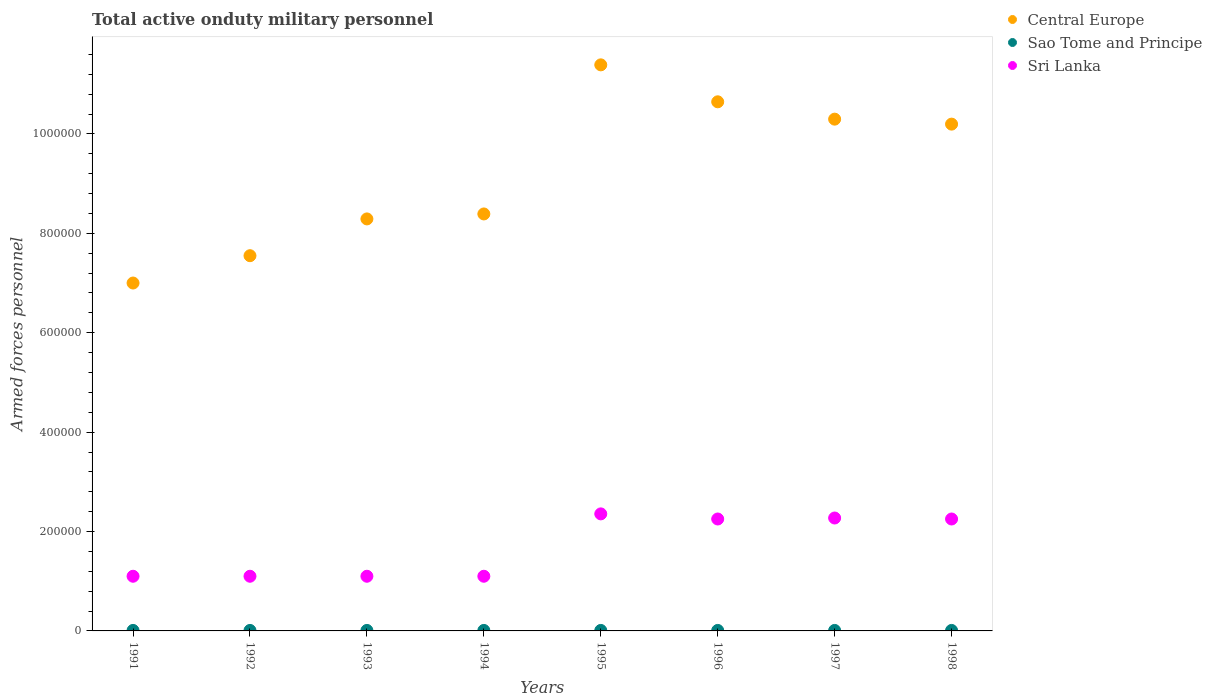How many different coloured dotlines are there?
Provide a short and direct response. 3. Is the number of dotlines equal to the number of legend labels?
Keep it short and to the point. Yes. What is the number of armed forces personnel in Central Europe in 1993?
Your answer should be compact. 8.29e+05. Across all years, what is the maximum number of armed forces personnel in Sri Lanka?
Provide a short and direct response. 2.36e+05. Across all years, what is the minimum number of armed forces personnel in Central Europe?
Give a very brief answer. 7.00e+05. In which year was the number of armed forces personnel in Sao Tome and Principe maximum?
Give a very brief answer. 1991. In which year was the number of armed forces personnel in Central Europe minimum?
Offer a terse response. 1991. What is the total number of armed forces personnel in Sri Lanka in the graph?
Offer a very short reply. 1.35e+06. What is the difference between the number of armed forces personnel in Sri Lanka in 1994 and that in 1995?
Offer a very short reply. -1.26e+05. What is the difference between the number of armed forces personnel in Central Europe in 1992 and the number of armed forces personnel in Sao Tome and Principe in 1994?
Keep it short and to the point. 7.54e+05. What is the average number of armed forces personnel in Central Europe per year?
Provide a succinct answer. 9.22e+05. In the year 1991, what is the difference between the number of armed forces personnel in Central Europe and number of armed forces personnel in Sao Tome and Principe?
Your answer should be compact. 6.99e+05. What is the ratio of the number of armed forces personnel in Sao Tome and Principe in 1996 to that in 1998?
Make the answer very short. 1. Is the number of armed forces personnel in Central Europe in 1993 less than that in 1997?
Give a very brief answer. Yes. Is the difference between the number of armed forces personnel in Central Europe in 1991 and 1993 greater than the difference between the number of armed forces personnel in Sao Tome and Principe in 1991 and 1993?
Your answer should be compact. No. What is the difference between the highest and the lowest number of armed forces personnel in Central Europe?
Your answer should be compact. 4.39e+05. Is the number of armed forces personnel in Central Europe strictly less than the number of armed forces personnel in Sao Tome and Principe over the years?
Your response must be concise. No. How many dotlines are there?
Your response must be concise. 3. How many years are there in the graph?
Give a very brief answer. 8. Are the values on the major ticks of Y-axis written in scientific E-notation?
Your answer should be compact. No. Does the graph contain any zero values?
Your response must be concise. No. Does the graph contain grids?
Your answer should be very brief. No. What is the title of the graph?
Ensure brevity in your answer.  Total active onduty military personnel. Does "Poland" appear as one of the legend labels in the graph?
Your answer should be compact. No. What is the label or title of the Y-axis?
Offer a terse response. Armed forces personnel. What is the Armed forces personnel of Central Europe in 1991?
Ensure brevity in your answer.  7.00e+05. What is the Armed forces personnel of Sri Lanka in 1991?
Provide a succinct answer. 1.10e+05. What is the Armed forces personnel in Central Europe in 1992?
Your response must be concise. 7.55e+05. What is the Armed forces personnel of Sao Tome and Principe in 1992?
Provide a short and direct response. 1000. What is the Armed forces personnel in Central Europe in 1993?
Make the answer very short. 8.29e+05. What is the Armed forces personnel in Sao Tome and Principe in 1993?
Your answer should be very brief. 1000. What is the Armed forces personnel in Central Europe in 1994?
Keep it short and to the point. 8.39e+05. What is the Armed forces personnel in Central Europe in 1995?
Offer a terse response. 1.14e+06. What is the Armed forces personnel in Sao Tome and Principe in 1995?
Offer a terse response. 1000. What is the Armed forces personnel in Sri Lanka in 1995?
Make the answer very short. 2.36e+05. What is the Armed forces personnel of Central Europe in 1996?
Your answer should be very brief. 1.06e+06. What is the Armed forces personnel of Sao Tome and Principe in 1996?
Make the answer very short. 1000. What is the Armed forces personnel of Sri Lanka in 1996?
Your answer should be compact. 2.25e+05. What is the Armed forces personnel of Central Europe in 1997?
Provide a short and direct response. 1.03e+06. What is the Armed forces personnel in Sao Tome and Principe in 1997?
Your answer should be very brief. 1000. What is the Armed forces personnel in Sri Lanka in 1997?
Keep it short and to the point. 2.27e+05. What is the Armed forces personnel of Central Europe in 1998?
Your answer should be very brief. 1.02e+06. What is the Armed forces personnel of Sao Tome and Principe in 1998?
Your answer should be compact. 1000. What is the Armed forces personnel in Sri Lanka in 1998?
Give a very brief answer. 2.25e+05. Across all years, what is the maximum Armed forces personnel of Central Europe?
Your answer should be compact. 1.14e+06. Across all years, what is the maximum Armed forces personnel of Sri Lanka?
Offer a very short reply. 2.36e+05. Across all years, what is the minimum Armed forces personnel of Sao Tome and Principe?
Keep it short and to the point. 1000. What is the total Armed forces personnel of Central Europe in the graph?
Make the answer very short. 7.38e+06. What is the total Armed forces personnel in Sao Tome and Principe in the graph?
Provide a succinct answer. 8000. What is the total Armed forces personnel in Sri Lanka in the graph?
Your answer should be compact. 1.35e+06. What is the difference between the Armed forces personnel in Central Europe in 1991 and that in 1992?
Offer a terse response. -5.50e+04. What is the difference between the Armed forces personnel of Sao Tome and Principe in 1991 and that in 1992?
Your answer should be very brief. 0. What is the difference between the Armed forces personnel in Central Europe in 1991 and that in 1993?
Keep it short and to the point. -1.29e+05. What is the difference between the Armed forces personnel of Sao Tome and Principe in 1991 and that in 1993?
Your answer should be compact. 0. What is the difference between the Armed forces personnel of Central Europe in 1991 and that in 1994?
Provide a short and direct response. -1.39e+05. What is the difference between the Armed forces personnel of Central Europe in 1991 and that in 1995?
Ensure brevity in your answer.  -4.39e+05. What is the difference between the Armed forces personnel of Sao Tome and Principe in 1991 and that in 1995?
Provide a short and direct response. 0. What is the difference between the Armed forces personnel of Sri Lanka in 1991 and that in 1995?
Ensure brevity in your answer.  -1.26e+05. What is the difference between the Armed forces personnel in Central Europe in 1991 and that in 1996?
Make the answer very short. -3.65e+05. What is the difference between the Armed forces personnel in Sri Lanka in 1991 and that in 1996?
Your response must be concise. -1.15e+05. What is the difference between the Armed forces personnel of Central Europe in 1991 and that in 1997?
Ensure brevity in your answer.  -3.30e+05. What is the difference between the Armed forces personnel of Sao Tome and Principe in 1991 and that in 1997?
Offer a terse response. 0. What is the difference between the Armed forces personnel in Sri Lanka in 1991 and that in 1997?
Provide a succinct answer. -1.17e+05. What is the difference between the Armed forces personnel in Central Europe in 1991 and that in 1998?
Offer a very short reply. -3.20e+05. What is the difference between the Armed forces personnel in Sri Lanka in 1991 and that in 1998?
Ensure brevity in your answer.  -1.15e+05. What is the difference between the Armed forces personnel of Central Europe in 1992 and that in 1993?
Give a very brief answer. -7.40e+04. What is the difference between the Armed forces personnel in Sri Lanka in 1992 and that in 1993?
Your answer should be compact. 0. What is the difference between the Armed forces personnel in Central Europe in 1992 and that in 1994?
Your response must be concise. -8.40e+04. What is the difference between the Armed forces personnel of Sao Tome and Principe in 1992 and that in 1994?
Provide a succinct answer. 0. What is the difference between the Armed forces personnel in Sri Lanka in 1992 and that in 1994?
Your answer should be very brief. 0. What is the difference between the Armed forces personnel in Central Europe in 1992 and that in 1995?
Make the answer very short. -3.84e+05. What is the difference between the Armed forces personnel in Sri Lanka in 1992 and that in 1995?
Make the answer very short. -1.26e+05. What is the difference between the Armed forces personnel in Central Europe in 1992 and that in 1996?
Keep it short and to the point. -3.10e+05. What is the difference between the Armed forces personnel of Sri Lanka in 1992 and that in 1996?
Offer a terse response. -1.15e+05. What is the difference between the Armed forces personnel in Central Europe in 1992 and that in 1997?
Offer a terse response. -2.75e+05. What is the difference between the Armed forces personnel in Sri Lanka in 1992 and that in 1997?
Your answer should be compact. -1.17e+05. What is the difference between the Armed forces personnel of Central Europe in 1992 and that in 1998?
Give a very brief answer. -2.65e+05. What is the difference between the Armed forces personnel in Sao Tome and Principe in 1992 and that in 1998?
Your answer should be very brief. 0. What is the difference between the Armed forces personnel of Sri Lanka in 1992 and that in 1998?
Make the answer very short. -1.15e+05. What is the difference between the Armed forces personnel in Central Europe in 1993 and that in 1994?
Offer a very short reply. -10000. What is the difference between the Armed forces personnel of Central Europe in 1993 and that in 1995?
Provide a succinct answer. -3.10e+05. What is the difference between the Armed forces personnel of Sri Lanka in 1993 and that in 1995?
Provide a short and direct response. -1.26e+05. What is the difference between the Armed forces personnel in Central Europe in 1993 and that in 1996?
Your response must be concise. -2.36e+05. What is the difference between the Armed forces personnel of Sao Tome and Principe in 1993 and that in 1996?
Provide a succinct answer. 0. What is the difference between the Armed forces personnel in Sri Lanka in 1993 and that in 1996?
Ensure brevity in your answer.  -1.15e+05. What is the difference between the Armed forces personnel of Central Europe in 1993 and that in 1997?
Provide a succinct answer. -2.01e+05. What is the difference between the Armed forces personnel of Sao Tome and Principe in 1993 and that in 1997?
Give a very brief answer. 0. What is the difference between the Armed forces personnel in Sri Lanka in 1993 and that in 1997?
Provide a succinct answer. -1.17e+05. What is the difference between the Armed forces personnel in Central Europe in 1993 and that in 1998?
Offer a terse response. -1.91e+05. What is the difference between the Armed forces personnel in Sri Lanka in 1993 and that in 1998?
Make the answer very short. -1.15e+05. What is the difference between the Armed forces personnel in Central Europe in 1994 and that in 1995?
Offer a terse response. -3.00e+05. What is the difference between the Armed forces personnel of Sao Tome and Principe in 1994 and that in 1995?
Ensure brevity in your answer.  0. What is the difference between the Armed forces personnel of Sri Lanka in 1994 and that in 1995?
Ensure brevity in your answer.  -1.26e+05. What is the difference between the Armed forces personnel of Central Europe in 1994 and that in 1996?
Provide a short and direct response. -2.26e+05. What is the difference between the Armed forces personnel of Sao Tome and Principe in 1994 and that in 1996?
Offer a very short reply. 0. What is the difference between the Armed forces personnel in Sri Lanka in 1994 and that in 1996?
Offer a very short reply. -1.15e+05. What is the difference between the Armed forces personnel of Central Europe in 1994 and that in 1997?
Your answer should be very brief. -1.91e+05. What is the difference between the Armed forces personnel in Sri Lanka in 1994 and that in 1997?
Ensure brevity in your answer.  -1.17e+05. What is the difference between the Armed forces personnel of Central Europe in 1994 and that in 1998?
Provide a succinct answer. -1.81e+05. What is the difference between the Armed forces personnel of Sri Lanka in 1994 and that in 1998?
Make the answer very short. -1.15e+05. What is the difference between the Armed forces personnel of Central Europe in 1995 and that in 1996?
Your answer should be very brief. 7.44e+04. What is the difference between the Armed forces personnel in Sri Lanka in 1995 and that in 1996?
Your answer should be very brief. 1.03e+04. What is the difference between the Armed forces personnel of Central Europe in 1995 and that in 1997?
Make the answer very short. 1.09e+05. What is the difference between the Armed forces personnel in Sao Tome and Principe in 1995 and that in 1997?
Your response must be concise. 0. What is the difference between the Armed forces personnel in Sri Lanka in 1995 and that in 1997?
Keep it short and to the point. 8300. What is the difference between the Armed forces personnel in Central Europe in 1995 and that in 1998?
Offer a terse response. 1.19e+05. What is the difference between the Armed forces personnel of Sri Lanka in 1995 and that in 1998?
Give a very brief answer. 1.03e+04. What is the difference between the Armed forces personnel in Central Europe in 1996 and that in 1997?
Give a very brief answer. 3.49e+04. What is the difference between the Armed forces personnel in Sao Tome and Principe in 1996 and that in 1997?
Offer a very short reply. 0. What is the difference between the Armed forces personnel in Sri Lanka in 1996 and that in 1997?
Keep it short and to the point. -2000. What is the difference between the Armed forces personnel of Central Europe in 1996 and that in 1998?
Give a very brief answer. 4.49e+04. What is the difference between the Armed forces personnel in Sao Tome and Principe in 1996 and that in 1998?
Offer a very short reply. 0. What is the difference between the Armed forces personnel in Central Europe in 1997 and that in 1998?
Keep it short and to the point. 1.00e+04. What is the difference between the Armed forces personnel in Central Europe in 1991 and the Armed forces personnel in Sao Tome and Principe in 1992?
Offer a terse response. 6.99e+05. What is the difference between the Armed forces personnel of Central Europe in 1991 and the Armed forces personnel of Sri Lanka in 1992?
Provide a succinct answer. 5.90e+05. What is the difference between the Armed forces personnel in Sao Tome and Principe in 1991 and the Armed forces personnel in Sri Lanka in 1992?
Your answer should be compact. -1.09e+05. What is the difference between the Armed forces personnel in Central Europe in 1991 and the Armed forces personnel in Sao Tome and Principe in 1993?
Provide a succinct answer. 6.99e+05. What is the difference between the Armed forces personnel in Central Europe in 1991 and the Armed forces personnel in Sri Lanka in 1993?
Offer a very short reply. 5.90e+05. What is the difference between the Armed forces personnel in Sao Tome and Principe in 1991 and the Armed forces personnel in Sri Lanka in 1993?
Give a very brief answer. -1.09e+05. What is the difference between the Armed forces personnel in Central Europe in 1991 and the Armed forces personnel in Sao Tome and Principe in 1994?
Ensure brevity in your answer.  6.99e+05. What is the difference between the Armed forces personnel of Central Europe in 1991 and the Armed forces personnel of Sri Lanka in 1994?
Provide a succinct answer. 5.90e+05. What is the difference between the Armed forces personnel of Sao Tome and Principe in 1991 and the Armed forces personnel of Sri Lanka in 1994?
Ensure brevity in your answer.  -1.09e+05. What is the difference between the Armed forces personnel in Central Europe in 1991 and the Armed forces personnel in Sao Tome and Principe in 1995?
Keep it short and to the point. 6.99e+05. What is the difference between the Armed forces personnel in Central Europe in 1991 and the Armed forces personnel in Sri Lanka in 1995?
Offer a terse response. 4.64e+05. What is the difference between the Armed forces personnel in Sao Tome and Principe in 1991 and the Armed forces personnel in Sri Lanka in 1995?
Ensure brevity in your answer.  -2.34e+05. What is the difference between the Armed forces personnel of Central Europe in 1991 and the Armed forces personnel of Sao Tome and Principe in 1996?
Provide a short and direct response. 6.99e+05. What is the difference between the Armed forces personnel of Central Europe in 1991 and the Armed forces personnel of Sri Lanka in 1996?
Offer a very short reply. 4.75e+05. What is the difference between the Armed forces personnel of Sao Tome and Principe in 1991 and the Armed forces personnel of Sri Lanka in 1996?
Offer a very short reply. -2.24e+05. What is the difference between the Armed forces personnel in Central Europe in 1991 and the Armed forces personnel in Sao Tome and Principe in 1997?
Provide a short and direct response. 6.99e+05. What is the difference between the Armed forces personnel in Central Europe in 1991 and the Armed forces personnel in Sri Lanka in 1997?
Your answer should be compact. 4.73e+05. What is the difference between the Armed forces personnel of Sao Tome and Principe in 1991 and the Armed forces personnel of Sri Lanka in 1997?
Give a very brief answer. -2.26e+05. What is the difference between the Armed forces personnel in Central Europe in 1991 and the Armed forces personnel in Sao Tome and Principe in 1998?
Offer a terse response. 6.99e+05. What is the difference between the Armed forces personnel in Central Europe in 1991 and the Armed forces personnel in Sri Lanka in 1998?
Ensure brevity in your answer.  4.75e+05. What is the difference between the Armed forces personnel of Sao Tome and Principe in 1991 and the Armed forces personnel of Sri Lanka in 1998?
Your answer should be compact. -2.24e+05. What is the difference between the Armed forces personnel in Central Europe in 1992 and the Armed forces personnel in Sao Tome and Principe in 1993?
Provide a short and direct response. 7.54e+05. What is the difference between the Armed forces personnel of Central Europe in 1992 and the Armed forces personnel of Sri Lanka in 1993?
Provide a short and direct response. 6.45e+05. What is the difference between the Armed forces personnel of Sao Tome and Principe in 1992 and the Armed forces personnel of Sri Lanka in 1993?
Make the answer very short. -1.09e+05. What is the difference between the Armed forces personnel in Central Europe in 1992 and the Armed forces personnel in Sao Tome and Principe in 1994?
Your answer should be compact. 7.54e+05. What is the difference between the Armed forces personnel of Central Europe in 1992 and the Armed forces personnel of Sri Lanka in 1994?
Your response must be concise. 6.45e+05. What is the difference between the Armed forces personnel in Sao Tome and Principe in 1992 and the Armed forces personnel in Sri Lanka in 1994?
Make the answer very short. -1.09e+05. What is the difference between the Armed forces personnel of Central Europe in 1992 and the Armed forces personnel of Sao Tome and Principe in 1995?
Your answer should be compact. 7.54e+05. What is the difference between the Armed forces personnel in Central Europe in 1992 and the Armed forces personnel in Sri Lanka in 1995?
Offer a very short reply. 5.20e+05. What is the difference between the Armed forces personnel of Sao Tome and Principe in 1992 and the Armed forces personnel of Sri Lanka in 1995?
Give a very brief answer. -2.34e+05. What is the difference between the Armed forces personnel in Central Europe in 1992 and the Armed forces personnel in Sao Tome and Principe in 1996?
Offer a terse response. 7.54e+05. What is the difference between the Armed forces personnel in Central Europe in 1992 and the Armed forces personnel in Sri Lanka in 1996?
Offer a very short reply. 5.30e+05. What is the difference between the Armed forces personnel in Sao Tome and Principe in 1992 and the Armed forces personnel in Sri Lanka in 1996?
Provide a succinct answer. -2.24e+05. What is the difference between the Armed forces personnel of Central Europe in 1992 and the Armed forces personnel of Sao Tome and Principe in 1997?
Your answer should be very brief. 7.54e+05. What is the difference between the Armed forces personnel in Central Europe in 1992 and the Armed forces personnel in Sri Lanka in 1997?
Give a very brief answer. 5.28e+05. What is the difference between the Armed forces personnel of Sao Tome and Principe in 1992 and the Armed forces personnel of Sri Lanka in 1997?
Make the answer very short. -2.26e+05. What is the difference between the Armed forces personnel in Central Europe in 1992 and the Armed forces personnel in Sao Tome and Principe in 1998?
Make the answer very short. 7.54e+05. What is the difference between the Armed forces personnel in Central Europe in 1992 and the Armed forces personnel in Sri Lanka in 1998?
Offer a terse response. 5.30e+05. What is the difference between the Armed forces personnel in Sao Tome and Principe in 1992 and the Armed forces personnel in Sri Lanka in 1998?
Your answer should be compact. -2.24e+05. What is the difference between the Armed forces personnel of Central Europe in 1993 and the Armed forces personnel of Sao Tome and Principe in 1994?
Your answer should be very brief. 8.28e+05. What is the difference between the Armed forces personnel of Central Europe in 1993 and the Armed forces personnel of Sri Lanka in 1994?
Your response must be concise. 7.19e+05. What is the difference between the Armed forces personnel of Sao Tome and Principe in 1993 and the Armed forces personnel of Sri Lanka in 1994?
Your answer should be very brief. -1.09e+05. What is the difference between the Armed forces personnel in Central Europe in 1993 and the Armed forces personnel in Sao Tome and Principe in 1995?
Keep it short and to the point. 8.28e+05. What is the difference between the Armed forces personnel in Central Europe in 1993 and the Armed forces personnel in Sri Lanka in 1995?
Ensure brevity in your answer.  5.94e+05. What is the difference between the Armed forces personnel in Sao Tome and Principe in 1993 and the Armed forces personnel in Sri Lanka in 1995?
Offer a terse response. -2.34e+05. What is the difference between the Armed forces personnel of Central Europe in 1993 and the Armed forces personnel of Sao Tome and Principe in 1996?
Keep it short and to the point. 8.28e+05. What is the difference between the Armed forces personnel in Central Europe in 1993 and the Armed forces personnel in Sri Lanka in 1996?
Offer a very short reply. 6.04e+05. What is the difference between the Armed forces personnel of Sao Tome and Principe in 1993 and the Armed forces personnel of Sri Lanka in 1996?
Your response must be concise. -2.24e+05. What is the difference between the Armed forces personnel in Central Europe in 1993 and the Armed forces personnel in Sao Tome and Principe in 1997?
Ensure brevity in your answer.  8.28e+05. What is the difference between the Armed forces personnel in Central Europe in 1993 and the Armed forces personnel in Sri Lanka in 1997?
Ensure brevity in your answer.  6.02e+05. What is the difference between the Armed forces personnel in Sao Tome and Principe in 1993 and the Armed forces personnel in Sri Lanka in 1997?
Your answer should be compact. -2.26e+05. What is the difference between the Armed forces personnel of Central Europe in 1993 and the Armed forces personnel of Sao Tome and Principe in 1998?
Your answer should be very brief. 8.28e+05. What is the difference between the Armed forces personnel in Central Europe in 1993 and the Armed forces personnel in Sri Lanka in 1998?
Your answer should be compact. 6.04e+05. What is the difference between the Armed forces personnel in Sao Tome and Principe in 1993 and the Armed forces personnel in Sri Lanka in 1998?
Keep it short and to the point. -2.24e+05. What is the difference between the Armed forces personnel of Central Europe in 1994 and the Armed forces personnel of Sao Tome and Principe in 1995?
Offer a terse response. 8.38e+05. What is the difference between the Armed forces personnel in Central Europe in 1994 and the Armed forces personnel in Sri Lanka in 1995?
Give a very brief answer. 6.04e+05. What is the difference between the Armed forces personnel in Sao Tome and Principe in 1994 and the Armed forces personnel in Sri Lanka in 1995?
Make the answer very short. -2.34e+05. What is the difference between the Armed forces personnel in Central Europe in 1994 and the Armed forces personnel in Sao Tome and Principe in 1996?
Your answer should be very brief. 8.38e+05. What is the difference between the Armed forces personnel of Central Europe in 1994 and the Armed forces personnel of Sri Lanka in 1996?
Offer a very short reply. 6.14e+05. What is the difference between the Armed forces personnel in Sao Tome and Principe in 1994 and the Armed forces personnel in Sri Lanka in 1996?
Provide a succinct answer. -2.24e+05. What is the difference between the Armed forces personnel in Central Europe in 1994 and the Armed forces personnel in Sao Tome and Principe in 1997?
Your response must be concise. 8.38e+05. What is the difference between the Armed forces personnel of Central Europe in 1994 and the Armed forces personnel of Sri Lanka in 1997?
Your answer should be compact. 6.12e+05. What is the difference between the Armed forces personnel of Sao Tome and Principe in 1994 and the Armed forces personnel of Sri Lanka in 1997?
Make the answer very short. -2.26e+05. What is the difference between the Armed forces personnel of Central Europe in 1994 and the Armed forces personnel of Sao Tome and Principe in 1998?
Your response must be concise. 8.38e+05. What is the difference between the Armed forces personnel in Central Europe in 1994 and the Armed forces personnel in Sri Lanka in 1998?
Ensure brevity in your answer.  6.14e+05. What is the difference between the Armed forces personnel in Sao Tome and Principe in 1994 and the Armed forces personnel in Sri Lanka in 1998?
Offer a terse response. -2.24e+05. What is the difference between the Armed forces personnel of Central Europe in 1995 and the Armed forces personnel of Sao Tome and Principe in 1996?
Provide a short and direct response. 1.14e+06. What is the difference between the Armed forces personnel of Central Europe in 1995 and the Armed forces personnel of Sri Lanka in 1996?
Ensure brevity in your answer.  9.14e+05. What is the difference between the Armed forces personnel in Sao Tome and Principe in 1995 and the Armed forces personnel in Sri Lanka in 1996?
Provide a succinct answer. -2.24e+05. What is the difference between the Armed forces personnel in Central Europe in 1995 and the Armed forces personnel in Sao Tome and Principe in 1997?
Provide a short and direct response. 1.14e+06. What is the difference between the Armed forces personnel in Central Europe in 1995 and the Armed forces personnel in Sri Lanka in 1997?
Offer a very short reply. 9.12e+05. What is the difference between the Armed forces personnel of Sao Tome and Principe in 1995 and the Armed forces personnel of Sri Lanka in 1997?
Your response must be concise. -2.26e+05. What is the difference between the Armed forces personnel of Central Europe in 1995 and the Armed forces personnel of Sao Tome and Principe in 1998?
Ensure brevity in your answer.  1.14e+06. What is the difference between the Armed forces personnel of Central Europe in 1995 and the Armed forces personnel of Sri Lanka in 1998?
Your answer should be very brief. 9.14e+05. What is the difference between the Armed forces personnel of Sao Tome and Principe in 1995 and the Armed forces personnel of Sri Lanka in 1998?
Make the answer very short. -2.24e+05. What is the difference between the Armed forces personnel in Central Europe in 1996 and the Armed forces personnel in Sao Tome and Principe in 1997?
Offer a terse response. 1.06e+06. What is the difference between the Armed forces personnel of Central Europe in 1996 and the Armed forces personnel of Sri Lanka in 1997?
Ensure brevity in your answer.  8.37e+05. What is the difference between the Armed forces personnel in Sao Tome and Principe in 1996 and the Armed forces personnel in Sri Lanka in 1997?
Provide a succinct answer. -2.26e+05. What is the difference between the Armed forces personnel of Central Europe in 1996 and the Armed forces personnel of Sao Tome and Principe in 1998?
Ensure brevity in your answer.  1.06e+06. What is the difference between the Armed forces personnel of Central Europe in 1996 and the Armed forces personnel of Sri Lanka in 1998?
Your response must be concise. 8.39e+05. What is the difference between the Armed forces personnel of Sao Tome and Principe in 1996 and the Armed forces personnel of Sri Lanka in 1998?
Give a very brief answer. -2.24e+05. What is the difference between the Armed forces personnel of Central Europe in 1997 and the Armed forces personnel of Sao Tome and Principe in 1998?
Your answer should be very brief. 1.03e+06. What is the difference between the Armed forces personnel of Central Europe in 1997 and the Armed forces personnel of Sri Lanka in 1998?
Ensure brevity in your answer.  8.05e+05. What is the difference between the Armed forces personnel in Sao Tome and Principe in 1997 and the Armed forces personnel in Sri Lanka in 1998?
Make the answer very short. -2.24e+05. What is the average Armed forces personnel in Central Europe per year?
Your response must be concise. 9.22e+05. What is the average Armed forces personnel of Sri Lanka per year?
Your answer should be compact. 1.69e+05. In the year 1991, what is the difference between the Armed forces personnel of Central Europe and Armed forces personnel of Sao Tome and Principe?
Provide a short and direct response. 6.99e+05. In the year 1991, what is the difference between the Armed forces personnel of Central Europe and Armed forces personnel of Sri Lanka?
Make the answer very short. 5.90e+05. In the year 1991, what is the difference between the Armed forces personnel in Sao Tome and Principe and Armed forces personnel in Sri Lanka?
Your answer should be compact. -1.09e+05. In the year 1992, what is the difference between the Armed forces personnel in Central Europe and Armed forces personnel in Sao Tome and Principe?
Ensure brevity in your answer.  7.54e+05. In the year 1992, what is the difference between the Armed forces personnel in Central Europe and Armed forces personnel in Sri Lanka?
Offer a terse response. 6.45e+05. In the year 1992, what is the difference between the Armed forces personnel in Sao Tome and Principe and Armed forces personnel in Sri Lanka?
Your answer should be very brief. -1.09e+05. In the year 1993, what is the difference between the Armed forces personnel of Central Europe and Armed forces personnel of Sao Tome and Principe?
Give a very brief answer. 8.28e+05. In the year 1993, what is the difference between the Armed forces personnel of Central Europe and Armed forces personnel of Sri Lanka?
Your answer should be very brief. 7.19e+05. In the year 1993, what is the difference between the Armed forces personnel in Sao Tome and Principe and Armed forces personnel in Sri Lanka?
Keep it short and to the point. -1.09e+05. In the year 1994, what is the difference between the Armed forces personnel in Central Europe and Armed forces personnel in Sao Tome and Principe?
Give a very brief answer. 8.38e+05. In the year 1994, what is the difference between the Armed forces personnel in Central Europe and Armed forces personnel in Sri Lanka?
Offer a very short reply. 7.29e+05. In the year 1994, what is the difference between the Armed forces personnel of Sao Tome and Principe and Armed forces personnel of Sri Lanka?
Ensure brevity in your answer.  -1.09e+05. In the year 1995, what is the difference between the Armed forces personnel of Central Europe and Armed forces personnel of Sao Tome and Principe?
Give a very brief answer. 1.14e+06. In the year 1995, what is the difference between the Armed forces personnel in Central Europe and Armed forces personnel in Sri Lanka?
Offer a terse response. 9.04e+05. In the year 1995, what is the difference between the Armed forces personnel in Sao Tome and Principe and Armed forces personnel in Sri Lanka?
Your answer should be very brief. -2.34e+05. In the year 1996, what is the difference between the Armed forces personnel of Central Europe and Armed forces personnel of Sao Tome and Principe?
Your response must be concise. 1.06e+06. In the year 1996, what is the difference between the Armed forces personnel in Central Europe and Armed forces personnel in Sri Lanka?
Keep it short and to the point. 8.39e+05. In the year 1996, what is the difference between the Armed forces personnel in Sao Tome and Principe and Armed forces personnel in Sri Lanka?
Make the answer very short. -2.24e+05. In the year 1997, what is the difference between the Armed forces personnel of Central Europe and Armed forces personnel of Sao Tome and Principe?
Offer a terse response. 1.03e+06. In the year 1997, what is the difference between the Armed forces personnel of Central Europe and Armed forces personnel of Sri Lanka?
Keep it short and to the point. 8.03e+05. In the year 1997, what is the difference between the Armed forces personnel of Sao Tome and Principe and Armed forces personnel of Sri Lanka?
Provide a succinct answer. -2.26e+05. In the year 1998, what is the difference between the Armed forces personnel of Central Europe and Armed forces personnel of Sao Tome and Principe?
Keep it short and to the point. 1.02e+06. In the year 1998, what is the difference between the Armed forces personnel in Central Europe and Armed forces personnel in Sri Lanka?
Provide a succinct answer. 7.95e+05. In the year 1998, what is the difference between the Armed forces personnel of Sao Tome and Principe and Armed forces personnel of Sri Lanka?
Your answer should be very brief. -2.24e+05. What is the ratio of the Armed forces personnel of Central Europe in 1991 to that in 1992?
Provide a short and direct response. 0.93. What is the ratio of the Armed forces personnel of Central Europe in 1991 to that in 1993?
Provide a short and direct response. 0.84. What is the ratio of the Armed forces personnel of Central Europe in 1991 to that in 1994?
Provide a short and direct response. 0.83. What is the ratio of the Armed forces personnel of Sao Tome and Principe in 1991 to that in 1994?
Your answer should be very brief. 1. What is the ratio of the Armed forces personnel in Sri Lanka in 1991 to that in 1994?
Make the answer very short. 1. What is the ratio of the Armed forces personnel in Central Europe in 1991 to that in 1995?
Make the answer very short. 0.61. What is the ratio of the Armed forces personnel of Sao Tome and Principe in 1991 to that in 1995?
Ensure brevity in your answer.  1. What is the ratio of the Armed forces personnel of Sri Lanka in 1991 to that in 1995?
Offer a very short reply. 0.47. What is the ratio of the Armed forces personnel of Central Europe in 1991 to that in 1996?
Your answer should be compact. 0.66. What is the ratio of the Armed forces personnel of Sri Lanka in 1991 to that in 1996?
Your answer should be compact. 0.49. What is the ratio of the Armed forces personnel of Central Europe in 1991 to that in 1997?
Offer a very short reply. 0.68. What is the ratio of the Armed forces personnel in Sri Lanka in 1991 to that in 1997?
Offer a terse response. 0.48. What is the ratio of the Armed forces personnel in Central Europe in 1991 to that in 1998?
Ensure brevity in your answer.  0.69. What is the ratio of the Armed forces personnel in Sao Tome and Principe in 1991 to that in 1998?
Your response must be concise. 1. What is the ratio of the Armed forces personnel of Sri Lanka in 1991 to that in 1998?
Provide a succinct answer. 0.49. What is the ratio of the Armed forces personnel in Central Europe in 1992 to that in 1993?
Offer a very short reply. 0.91. What is the ratio of the Armed forces personnel of Sri Lanka in 1992 to that in 1993?
Offer a terse response. 1. What is the ratio of the Armed forces personnel in Central Europe in 1992 to that in 1994?
Offer a very short reply. 0.9. What is the ratio of the Armed forces personnel in Central Europe in 1992 to that in 1995?
Ensure brevity in your answer.  0.66. What is the ratio of the Armed forces personnel in Sri Lanka in 1992 to that in 1995?
Your answer should be very brief. 0.47. What is the ratio of the Armed forces personnel in Central Europe in 1992 to that in 1996?
Make the answer very short. 0.71. What is the ratio of the Armed forces personnel in Sao Tome and Principe in 1992 to that in 1996?
Offer a terse response. 1. What is the ratio of the Armed forces personnel in Sri Lanka in 1992 to that in 1996?
Make the answer very short. 0.49. What is the ratio of the Armed forces personnel in Central Europe in 1992 to that in 1997?
Provide a succinct answer. 0.73. What is the ratio of the Armed forces personnel in Sao Tome and Principe in 1992 to that in 1997?
Provide a short and direct response. 1. What is the ratio of the Armed forces personnel of Sri Lanka in 1992 to that in 1997?
Provide a succinct answer. 0.48. What is the ratio of the Armed forces personnel in Central Europe in 1992 to that in 1998?
Give a very brief answer. 0.74. What is the ratio of the Armed forces personnel in Sao Tome and Principe in 1992 to that in 1998?
Give a very brief answer. 1. What is the ratio of the Armed forces personnel in Sri Lanka in 1992 to that in 1998?
Ensure brevity in your answer.  0.49. What is the ratio of the Armed forces personnel of Central Europe in 1993 to that in 1994?
Offer a terse response. 0.99. What is the ratio of the Armed forces personnel in Sao Tome and Principe in 1993 to that in 1994?
Make the answer very short. 1. What is the ratio of the Armed forces personnel in Central Europe in 1993 to that in 1995?
Ensure brevity in your answer.  0.73. What is the ratio of the Armed forces personnel in Sri Lanka in 1993 to that in 1995?
Provide a succinct answer. 0.47. What is the ratio of the Armed forces personnel of Central Europe in 1993 to that in 1996?
Your answer should be compact. 0.78. What is the ratio of the Armed forces personnel in Sri Lanka in 1993 to that in 1996?
Give a very brief answer. 0.49. What is the ratio of the Armed forces personnel in Central Europe in 1993 to that in 1997?
Provide a succinct answer. 0.81. What is the ratio of the Armed forces personnel of Sao Tome and Principe in 1993 to that in 1997?
Provide a short and direct response. 1. What is the ratio of the Armed forces personnel of Sri Lanka in 1993 to that in 1997?
Offer a very short reply. 0.48. What is the ratio of the Armed forces personnel of Central Europe in 1993 to that in 1998?
Offer a terse response. 0.81. What is the ratio of the Armed forces personnel of Sri Lanka in 1993 to that in 1998?
Give a very brief answer. 0.49. What is the ratio of the Armed forces personnel in Central Europe in 1994 to that in 1995?
Your response must be concise. 0.74. What is the ratio of the Armed forces personnel of Sri Lanka in 1994 to that in 1995?
Your answer should be compact. 0.47. What is the ratio of the Armed forces personnel of Central Europe in 1994 to that in 1996?
Provide a succinct answer. 0.79. What is the ratio of the Armed forces personnel in Sao Tome and Principe in 1994 to that in 1996?
Provide a succinct answer. 1. What is the ratio of the Armed forces personnel of Sri Lanka in 1994 to that in 1996?
Provide a short and direct response. 0.49. What is the ratio of the Armed forces personnel of Central Europe in 1994 to that in 1997?
Ensure brevity in your answer.  0.81. What is the ratio of the Armed forces personnel in Sri Lanka in 1994 to that in 1997?
Your response must be concise. 0.48. What is the ratio of the Armed forces personnel of Central Europe in 1994 to that in 1998?
Offer a very short reply. 0.82. What is the ratio of the Armed forces personnel in Sao Tome and Principe in 1994 to that in 1998?
Your response must be concise. 1. What is the ratio of the Armed forces personnel of Sri Lanka in 1994 to that in 1998?
Make the answer very short. 0.49. What is the ratio of the Armed forces personnel of Central Europe in 1995 to that in 1996?
Offer a terse response. 1.07. What is the ratio of the Armed forces personnel in Sri Lanka in 1995 to that in 1996?
Offer a terse response. 1.05. What is the ratio of the Armed forces personnel of Central Europe in 1995 to that in 1997?
Offer a very short reply. 1.11. What is the ratio of the Armed forces personnel in Sao Tome and Principe in 1995 to that in 1997?
Your response must be concise. 1. What is the ratio of the Armed forces personnel of Sri Lanka in 1995 to that in 1997?
Offer a terse response. 1.04. What is the ratio of the Armed forces personnel of Central Europe in 1995 to that in 1998?
Offer a terse response. 1.12. What is the ratio of the Armed forces personnel in Sao Tome and Principe in 1995 to that in 1998?
Provide a short and direct response. 1. What is the ratio of the Armed forces personnel of Sri Lanka in 1995 to that in 1998?
Ensure brevity in your answer.  1.05. What is the ratio of the Armed forces personnel in Central Europe in 1996 to that in 1997?
Make the answer very short. 1.03. What is the ratio of the Armed forces personnel of Sri Lanka in 1996 to that in 1997?
Your response must be concise. 0.99. What is the ratio of the Armed forces personnel of Central Europe in 1996 to that in 1998?
Make the answer very short. 1.04. What is the ratio of the Armed forces personnel in Central Europe in 1997 to that in 1998?
Give a very brief answer. 1.01. What is the ratio of the Armed forces personnel of Sao Tome and Principe in 1997 to that in 1998?
Give a very brief answer. 1. What is the ratio of the Armed forces personnel in Sri Lanka in 1997 to that in 1998?
Ensure brevity in your answer.  1.01. What is the difference between the highest and the second highest Armed forces personnel in Central Europe?
Offer a very short reply. 7.44e+04. What is the difference between the highest and the second highest Armed forces personnel in Sri Lanka?
Provide a short and direct response. 8300. What is the difference between the highest and the lowest Armed forces personnel in Central Europe?
Your response must be concise. 4.39e+05. What is the difference between the highest and the lowest Armed forces personnel in Sao Tome and Principe?
Offer a very short reply. 0. What is the difference between the highest and the lowest Armed forces personnel of Sri Lanka?
Your answer should be very brief. 1.26e+05. 